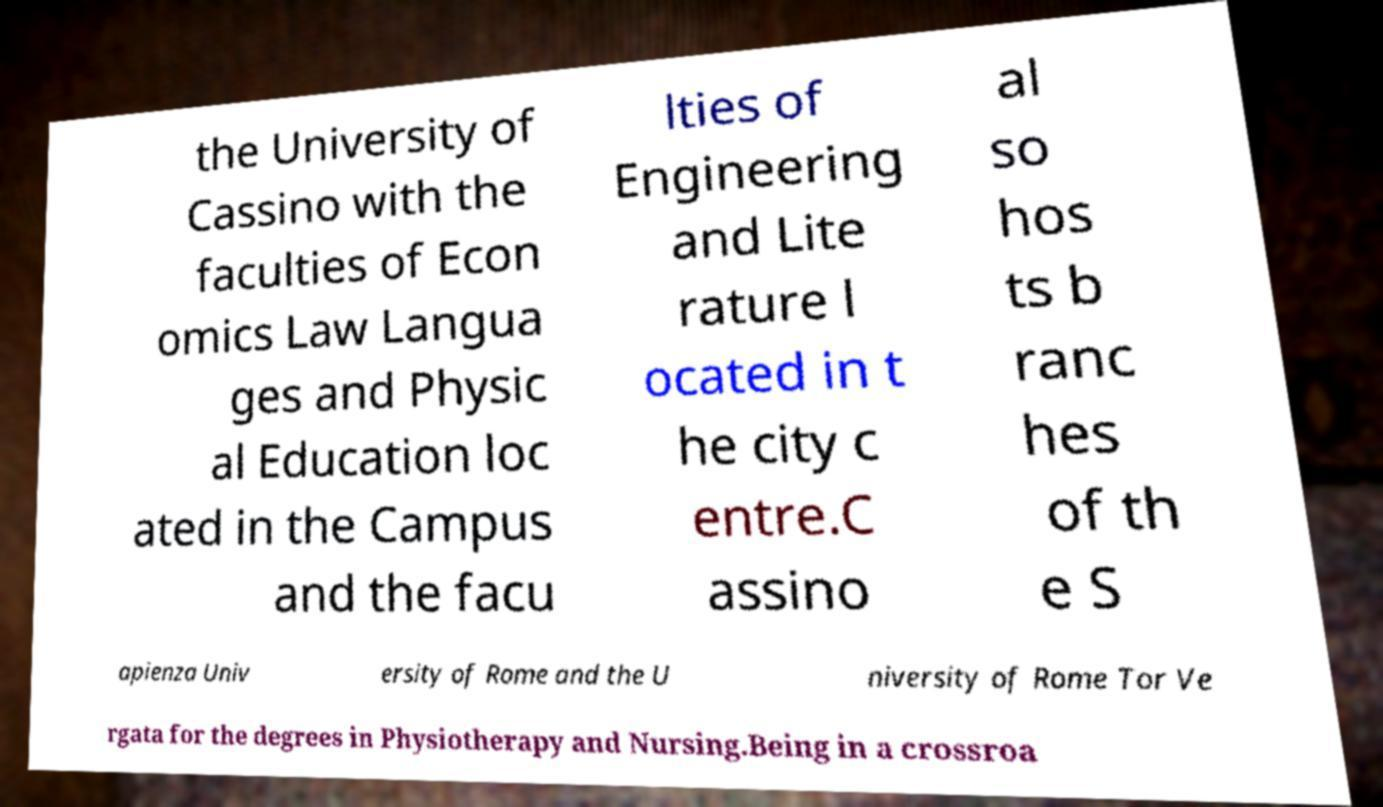There's text embedded in this image that I need extracted. Can you transcribe it verbatim? the University of Cassino with the faculties of Econ omics Law Langua ges and Physic al Education loc ated in the Campus and the facu lties of Engineering and Lite rature l ocated in t he city c entre.C assino al so hos ts b ranc hes of th e S apienza Univ ersity of Rome and the U niversity of Rome Tor Ve rgata for the degrees in Physiotherapy and Nursing.Being in a crossroa 